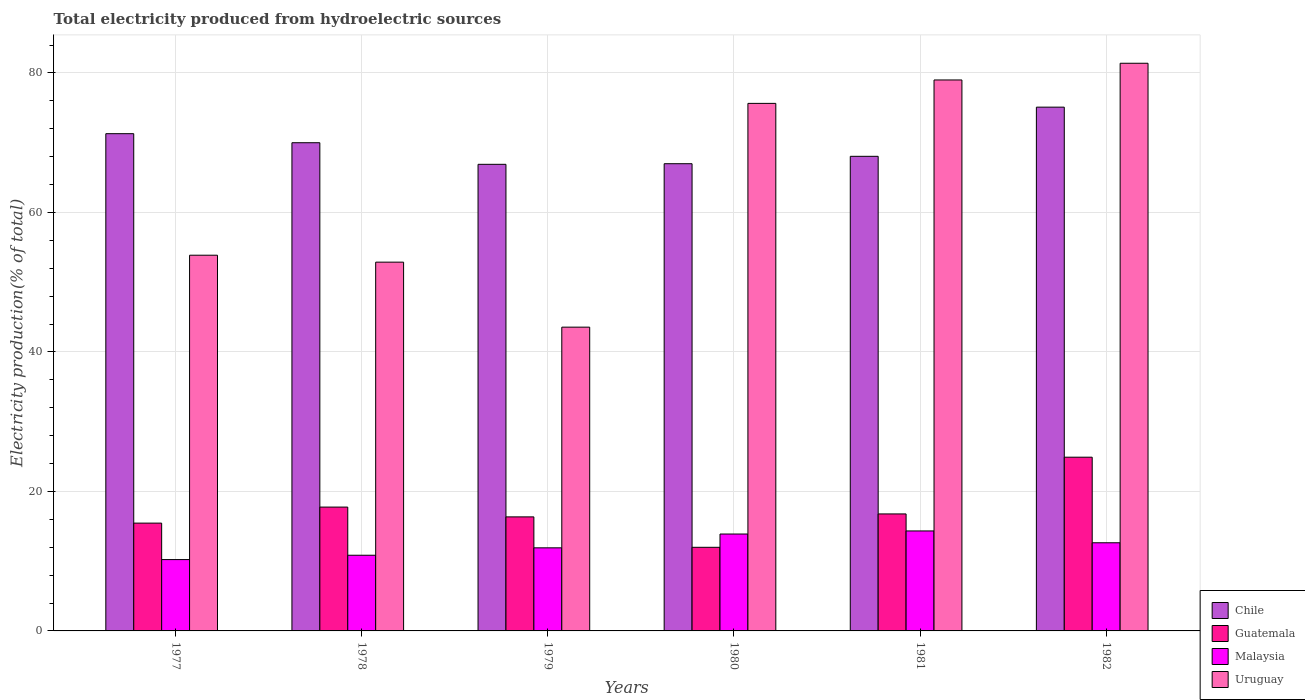How many groups of bars are there?
Ensure brevity in your answer.  6. How many bars are there on the 1st tick from the left?
Offer a terse response. 4. How many bars are there on the 3rd tick from the right?
Offer a terse response. 4. What is the label of the 4th group of bars from the left?
Your answer should be compact. 1980. What is the total electricity produced in Chile in 1977?
Your answer should be very brief. 71.29. Across all years, what is the maximum total electricity produced in Chile?
Your answer should be very brief. 75.09. Across all years, what is the minimum total electricity produced in Chile?
Provide a succinct answer. 66.89. In which year was the total electricity produced in Guatemala maximum?
Make the answer very short. 1982. In which year was the total electricity produced in Malaysia minimum?
Your answer should be very brief. 1977. What is the total total electricity produced in Malaysia in the graph?
Provide a succinct answer. 73.85. What is the difference between the total electricity produced in Malaysia in 1977 and that in 1978?
Keep it short and to the point. -0.62. What is the difference between the total electricity produced in Chile in 1982 and the total electricity produced in Malaysia in 1980?
Give a very brief answer. 61.2. What is the average total electricity produced in Malaysia per year?
Your answer should be compact. 12.31. In the year 1979, what is the difference between the total electricity produced in Malaysia and total electricity produced in Guatemala?
Your response must be concise. -4.44. In how many years, is the total electricity produced in Malaysia greater than 56 %?
Your answer should be very brief. 0. What is the ratio of the total electricity produced in Malaysia in 1980 to that in 1982?
Provide a short and direct response. 1.1. Is the difference between the total electricity produced in Malaysia in 1979 and 1981 greater than the difference between the total electricity produced in Guatemala in 1979 and 1981?
Offer a terse response. No. What is the difference between the highest and the second highest total electricity produced in Chile?
Your answer should be compact. 3.8. What is the difference between the highest and the lowest total electricity produced in Uruguay?
Provide a short and direct response. 37.83. Is the sum of the total electricity produced in Uruguay in 1978 and 1982 greater than the maximum total electricity produced in Chile across all years?
Make the answer very short. Yes. Is it the case that in every year, the sum of the total electricity produced in Malaysia and total electricity produced in Uruguay is greater than the sum of total electricity produced in Guatemala and total electricity produced in Chile?
Offer a very short reply. Yes. What does the 2nd bar from the left in 1979 represents?
Keep it short and to the point. Guatemala. What does the 4th bar from the right in 1979 represents?
Your answer should be compact. Chile. Are all the bars in the graph horizontal?
Your answer should be compact. No. How many years are there in the graph?
Give a very brief answer. 6. What is the difference between two consecutive major ticks on the Y-axis?
Your response must be concise. 20. Are the values on the major ticks of Y-axis written in scientific E-notation?
Keep it short and to the point. No. Where does the legend appear in the graph?
Your answer should be very brief. Bottom right. How many legend labels are there?
Your response must be concise. 4. How are the legend labels stacked?
Your answer should be very brief. Vertical. What is the title of the graph?
Your answer should be very brief. Total electricity produced from hydroelectric sources. Does "Iceland" appear as one of the legend labels in the graph?
Keep it short and to the point. No. What is the Electricity production(% of total) in Chile in 1977?
Offer a terse response. 71.29. What is the Electricity production(% of total) in Guatemala in 1977?
Offer a very short reply. 15.46. What is the Electricity production(% of total) in Malaysia in 1977?
Make the answer very short. 10.23. What is the Electricity production(% of total) of Uruguay in 1977?
Provide a short and direct response. 53.86. What is the Electricity production(% of total) of Chile in 1978?
Provide a short and direct response. 69.99. What is the Electricity production(% of total) in Guatemala in 1978?
Offer a terse response. 17.75. What is the Electricity production(% of total) of Malaysia in 1978?
Offer a very short reply. 10.85. What is the Electricity production(% of total) of Uruguay in 1978?
Give a very brief answer. 52.87. What is the Electricity production(% of total) of Chile in 1979?
Offer a very short reply. 66.89. What is the Electricity production(% of total) of Guatemala in 1979?
Provide a succinct answer. 16.35. What is the Electricity production(% of total) of Malaysia in 1979?
Your response must be concise. 11.91. What is the Electricity production(% of total) of Uruguay in 1979?
Keep it short and to the point. 43.55. What is the Electricity production(% of total) of Chile in 1980?
Make the answer very short. 66.98. What is the Electricity production(% of total) of Guatemala in 1980?
Your response must be concise. 11.99. What is the Electricity production(% of total) in Malaysia in 1980?
Your response must be concise. 13.89. What is the Electricity production(% of total) in Uruguay in 1980?
Your response must be concise. 75.63. What is the Electricity production(% of total) in Chile in 1981?
Make the answer very short. 68.04. What is the Electricity production(% of total) in Guatemala in 1981?
Ensure brevity in your answer.  16.77. What is the Electricity production(% of total) of Malaysia in 1981?
Provide a succinct answer. 14.33. What is the Electricity production(% of total) of Uruguay in 1981?
Your answer should be very brief. 78.99. What is the Electricity production(% of total) in Chile in 1982?
Your response must be concise. 75.09. What is the Electricity production(% of total) in Guatemala in 1982?
Your answer should be very brief. 24.91. What is the Electricity production(% of total) of Malaysia in 1982?
Make the answer very short. 12.64. What is the Electricity production(% of total) in Uruguay in 1982?
Your response must be concise. 81.38. Across all years, what is the maximum Electricity production(% of total) of Chile?
Keep it short and to the point. 75.09. Across all years, what is the maximum Electricity production(% of total) of Guatemala?
Offer a terse response. 24.91. Across all years, what is the maximum Electricity production(% of total) in Malaysia?
Your answer should be compact. 14.33. Across all years, what is the maximum Electricity production(% of total) in Uruguay?
Give a very brief answer. 81.38. Across all years, what is the minimum Electricity production(% of total) in Chile?
Make the answer very short. 66.89. Across all years, what is the minimum Electricity production(% of total) in Guatemala?
Ensure brevity in your answer.  11.99. Across all years, what is the minimum Electricity production(% of total) of Malaysia?
Give a very brief answer. 10.23. Across all years, what is the minimum Electricity production(% of total) of Uruguay?
Give a very brief answer. 43.55. What is the total Electricity production(% of total) of Chile in the graph?
Your response must be concise. 418.28. What is the total Electricity production(% of total) of Guatemala in the graph?
Your answer should be very brief. 103.23. What is the total Electricity production(% of total) of Malaysia in the graph?
Make the answer very short. 73.85. What is the total Electricity production(% of total) in Uruguay in the graph?
Ensure brevity in your answer.  386.29. What is the difference between the Electricity production(% of total) in Chile in 1977 and that in 1978?
Your answer should be compact. 1.3. What is the difference between the Electricity production(% of total) of Guatemala in 1977 and that in 1978?
Give a very brief answer. -2.3. What is the difference between the Electricity production(% of total) of Malaysia in 1977 and that in 1978?
Ensure brevity in your answer.  -0.62. What is the difference between the Electricity production(% of total) in Uruguay in 1977 and that in 1978?
Your response must be concise. 1. What is the difference between the Electricity production(% of total) of Chile in 1977 and that in 1979?
Your answer should be compact. 4.39. What is the difference between the Electricity production(% of total) in Guatemala in 1977 and that in 1979?
Make the answer very short. -0.89. What is the difference between the Electricity production(% of total) in Malaysia in 1977 and that in 1979?
Make the answer very short. -1.69. What is the difference between the Electricity production(% of total) in Uruguay in 1977 and that in 1979?
Ensure brevity in your answer.  10.31. What is the difference between the Electricity production(% of total) of Chile in 1977 and that in 1980?
Offer a terse response. 4.31. What is the difference between the Electricity production(% of total) of Guatemala in 1977 and that in 1980?
Keep it short and to the point. 3.47. What is the difference between the Electricity production(% of total) of Malaysia in 1977 and that in 1980?
Provide a succinct answer. -3.67. What is the difference between the Electricity production(% of total) in Uruguay in 1977 and that in 1980?
Your response must be concise. -21.77. What is the difference between the Electricity production(% of total) in Chile in 1977 and that in 1981?
Provide a succinct answer. 3.25. What is the difference between the Electricity production(% of total) in Guatemala in 1977 and that in 1981?
Provide a short and direct response. -1.32. What is the difference between the Electricity production(% of total) in Malaysia in 1977 and that in 1981?
Offer a very short reply. -4.11. What is the difference between the Electricity production(% of total) of Uruguay in 1977 and that in 1981?
Ensure brevity in your answer.  -25.12. What is the difference between the Electricity production(% of total) of Chile in 1977 and that in 1982?
Keep it short and to the point. -3.8. What is the difference between the Electricity production(% of total) in Guatemala in 1977 and that in 1982?
Provide a short and direct response. -9.45. What is the difference between the Electricity production(% of total) of Malaysia in 1977 and that in 1982?
Offer a very short reply. -2.41. What is the difference between the Electricity production(% of total) of Uruguay in 1977 and that in 1982?
Provide a succinct answer. -27.52. What is the difference between the Electricity production(% of total) in Chile in 1978 and that in 1979?
Offer a terse response. 3.1. What is the difference between the Electricity production(% of total) of Guatemala in 1978 and that in 1979?
Offer a terse response. 1.4. What is the difference between the Electricity production(% of total) in Malaysia in 1978 and that in 1979?
Offer a terse response. -1.06. What is the difference between the Electricity production(% of total) of Uruguay in 1978 and that in 1979?
Your response must be concise. 9.32. What is the difference between the Electricity production(% of total) of Chile in 1978 and that in 1980?
Your response must be concise. 3.01. What is the difference between the Electricity production(% of total) in Guatemala in 1978 and that in 1980?
Keep it short and to the point. 5.77. What is the difference between the Electricity production(% of total) in Malaysia in 1978 and that in 1980?
Keep it short and to the point. -3.04. What is the difference between the Electricity production(% of total) in Uruguay in 1978 and that in 1980?
Offer a very short reply. -22.76. What is the difference between the Electricity production(% of total) of Chile in 1978 and that in 1981?
Keep it short and to the point. 1.95. What is the difference between the Electricity production(% of total) of Guatemala in 1978 and that in 1981?
Provide a succinct answer. 0.98. What is the difference between the Electricity production(% of total) in Malaysia in 1978 and that in 1981?
Provide a succinct answer. -3.48. What is the difference between the Electricity production(% of total) of Uruguay in 1978 and that in 1981?
Give a very brief answer. -26.12. What is the difference between the Electricity production(% of total) in Chile in 1978 and that in 1982?
Your answer should be very brief. -5.1. What is the difference between the Electricity production(% of total) of Guatemala in 1978 and that in 1982?
Provide a short and direct response. -7.15. What is the difference between the Electricity production(% of total) of Malaysia in 1978 and that in 1982?
Make the answer very short. -1.79. What is the difference between the Electricity production(% of total) in Uruguay in 1978 and that in 1982?
Offer a very short reply. -28.52. What is the difference between the Electricity production(% of total) of Chile in 1979 and that in 1980?
Offer a terse response. -0.09. What is the difference between the Electricity production(% of total) of Guatemala in 1979 and that in 1980?
Your answer should be compact. 4.36. What is the difference between the Electricity production(% of total) in Malaysia in 1979 and that in 1980?
Keep it short and to the point. -1.98. What is the difference between the Electricity production(% of total) of Uruguay in 1979 and that in 1980?
Offer a terse response. -32.08. What is the difference between the Electricity production(% of total) in Chile in 1979 and that in 1981?
Your answer should be very brief. -1.15. What is the difference between the Electricity production(% of total) in Guatemala in 1979 and that in 1981?
Your answer should be compact. -0.42. What is the difference between the Electricity production(% of total) in Malaysia in 1979 and that in 1981?
Provide a short and direct response. -2.42. What is the difference between the Electricity production(% of total) in Uruguay in 1979 and that in 1981?
Your answer should be compact. -35.44. What is the difference between the Electricity production(% of total) of Chile in 1979 and that in 1982?
Provide a short and direct response. -8.2. What is the difference between the Electricity production(% of total) of Guatemala in 1979 and that in 1982?
Offer a very short reply. -8.56. What is the difference between the Electricity production(% of total) of Malaysia in 1979 and that in 1982?
Ensure brevity in your answer.  -0.73. What is the difference between the Electricity production(% of total) in Uruguay in 1979 and that in 1982?
Provide a short and direct response. -37.83. What is the difference between the Electricity production(% of total) of Chile in 1980 and that in 1981?
Your response must be concise. -1.06. What is the difference between the Electricity production(% of total) in Guatemala in 1980 and that in 1981?
Your answer should be very brief. -4.79. What is the difference between the Electricity production(% of total) of Malaysia in 1980 and that in 1981?
Keep it short and to the point. -0.44. What is the difference between the Electricity production(% of total) of Uruguay in 1980 and that in 1981?
Ensure brevity in your answer.  -3.36. What is the difference between the Electricity production(% of total) in Chile in 1980 and that in 1982?
Ensure brevity in your answer.  -8.11. What is the difference between the Electricity production(% of total) in Guatemala in 1980 and that in 1982?
Ensure brevity in your answer.  -12.92. What is the difference between the Electricity production(% of total) of Malaysia in 1980 and that in 1982?
Give a very brief answer. 1.25. What is the difference between the Electricity production(% of total) of Uruguay in 1980 and that in 1982?
Ensure brevity in your answer.  -5.75. What is the difference between the Electricity production(% of total) of Chile in 1981 and that in 1982?
Keep it short and to the point. -7.05. What is the difference between the Electricity production(% of total) of Guatemala in 1981 and that in 1982?
Offer a very short reply. -8.13. What is the difference between the Electricity production(% of total) of Malaysia in 1981 and that in 1982?
Ensure brevity in your answer.  1.7. What is the difference between the Electricity production(% of total) in Uruguay in 1981 and that in 1982?
Your response must be concise. -2.4. What is the difference between the Electricity production(% of total) of Chile in 1977 and the Electricity production(% of total) of Guatemala in 1978?
Ensure brevity in your answer.  53.53. What is the difference between the Electricity production(% of total) in Chile in 1977 and the Electricity production(% of total) in Malaysia in 1978?
Ensure brevity in your answer.  60.44. What is the difference between the Electricity production(% of total) in Chile in 1977 and the Electricity production(% of total) in Uruguay in 1978?
Give a very brief answer. 18.42. What is the difference between the Electricity production(% of total) of Guatemala in 1977 and the Electricity production(% of total) of Malaysia in 1978?
Your answer should be compact. 4.61. What is the difference between the Electricity production(% of total) in Guatemala in 1977 and the Electricity production(% of total) in Uruguay in 1978?
Your answer should be very brief. -37.41. What is the difference between the Electricity production(% of total) of Malaysia in 1977 and the Electricity production(% of total) of Uruguay in 1978?
Your answer should be very brief. -42.64. What is the difference between the Electricity production(% of total) of Chile in 1977 and the Electricity production(% of total) of Guatemala in 1979?
Keep it short and to the point. 54.94. What is the difference between the Electricity production(% of total) of Chile in 1977 and the Electricity production(% of total) of Malaysia in 1979?
Provide a short and direct response. 59.38. What is the difference between the Electricity production(% of total) in Chile in 1977 and the Electricity production(% of total) in Uruguay in 1979?
Your response must be concise. 27.74. What is the difference between the Electricity production(% of total) of Guatemala in 1977 and the Electricity production(% of total) of Malaysia in 1979?
Your answer should be very brief. 3.54. What is the difference between the Electricity production(% of total) in Guatemala in 1977 and the Electricity production(% of total) in Uruguay in 1979?
Offer a terse response. -28.1. What is the difference between the Electricity production(% of total) of Malaysia in 1977 and the Electricity production(% of total) of Uruguay in 1979?
Your response must be concise. -33.33. What is the difference between the Electricity production(% of total) in Chile in 1977 and the Electricity production(% of total) in Guatemala in 1980?
Offer a terse response. 59.3. What is the difference between the Electricity production(% of total) of Chile in 1977 and the Electricity production(% of total) of Malaysia in 1980?
Provide a succinct answer. 57.39. What is the difference between the Electricity production(% of total) of Chile in 1977 and the Electricity production(% of total) of Uruguay in 1980?
Provide a short and direct response. -4.34. What is the difference between the Electricity production(% of total) in Guatemala in 1977 and the Electricity production(% of total) in Malaysia in 1980?
Ensure brevity in your answer.  1.56. What is the difference between the Electricity production(% of total) of Guatemala in 1977 and the Electricity production(% of total) of Uruguay in 1980?
Provide a short and direct response. -60.17. What is the difference between the Electricity production(% of total) of Malaysia in 1977 and the Electricity production(% of total) of Uruguay in 1980?
Provide a short and direct response. -65.4. What is the difference between the Electricity production(% of total) in Chile in 1977 and the Electricity production(% of total) in Guatemala in 1981?
Keep it short and to the point. 54.51. What is the difference between the Electricity production(% of total) of Chile in 1977 and the Electricity production(% of total) of Malaysia in 1981?
Your response must be concise. 56.95. What is the difference between the Electricity production(% of total) of Chile in 1977 and the Electricity production(% of total) of Uruguay in 1981?
Offer a very short reply. -7.7. What is the difference between the Electricity production(% of total) of Guatemala in 1977 and the Electricity production(% of total) of Malaysia in 1981?
Make the answer very short. 1.12. What is the difference between the Electricity production(% of total) of Guatemala in 1977 and the Electricity production(% of total) of Uruguay in 1981?
Give a very brief answer. -63.53. What is the difference between the Electricity production(% of total) in Malaysia in 1977 and the Electricity production(% of total) in Uruguay in 1981?
Give a very brief answer. -68.76. What is the difference between the Electricity production(% of total) in Chile in 1977 and the Electricity production(% of total) in Guatemala in 1982?
Provide a short and direct response. 46.38. What is the difference between the Electricity production(% of total) in Chile in 1977 and the Electricity production(% of total) in Malaysia in 1982?
Make the answer very short. 58.65. What is the difference between the Electricity production(% of total) in Chile in 1977 and the Electricity production(% of total) in Uruguay in 1982?
Keep it short and to the point. -10.1. What is the difference between the Electricity production(% of total) in Guatemala in 1977 and the Electricity production(% of total) in Malaysia in 1982?
Ensure brevity in your answer.  2.82. What is the difference between the Electricity production(% of total) in Guatemala in 1977 and the Electricity production(% of total) in Uruguay in 1982?
Give a very brief answer. -65.93. What is the difference between the Electricity production(% of total) of Malaysia in 1977 and the Electricity production(% of total) of Uruguay in 1982?
Keep it short and to the point. -71.16. What is the difference between the Electricity production(% of total) of Chile in 1978 and the Electricity production(% of total) of Guatemala in 1979?
Offer a terse response. 53.64. What is the difference between the Electricity production(% of total) in Chile in 1978 and the Electricity production(% of total) in Malaysia in 1979?
Ensure brevity in your answer.  58.08. What is the difference between the Electricity production(% of total) in Chile in 1978 and the Electricity production(% of total) in Uruguay in 1979?
Offer a very short reply. 26.44. What is the difference between the Electricity production(% of total) in Guatemala in 1978 and the Electricity production(% of total) in Malaysia in 1979?
Offer a terse response. 5.84. What is the difference between the Electricity production(% of total) in Guatemala in 1978 and the Electricity production(% of total) in Uruguay in 1979?
Give a very brief answer. -25.8. What is the difference between the Electricity production(% of total) in Malaysia in 1978 and the Electricity production(% of total) in Uruguay in 1979?
Ensure brevity in your answer.  -32.7. What is the difference between the Electricity production(% of total) in Chile in 1978 and the Electricity production(% of total) in Guatemala in 1980?
Your answer should be compact. 58. What is the difference between the Electricity production(% of total) in Chile in 1978 and the Electricity production(% of total) in Malaysia in 1980?
Your response must be concise. 56.1. What is the difference between the Electricity production(% of total) of Chile in 1978 and the Electricity production(% of total) of Uruguay in 1980?
Offer a very short reply. -5.64. What is the difference between the Electricity production(% of total) in Guatemala in 1978 and the Electricity production(% of total) in Malaysia in 1980?
Ensure brevity in your answer.  3.86. What is the difference between the Electricity production(% of total) of Guatemala in 1978 and the Electricity production(% of total) of Uruguay in 1980?
Your answer should be very brief. -57.88. What is the difference between the Electricity production(% of total) of Malaysia in 1978 and the Electricity production(% of total) of Uruguay in 1980?
Provide a short and direct response. -64.78. What is the difference between the Electricity production(% of total) of Chile in 1978 and the Electricity production(% of total) of Guatemala in 1981?
Give a very brief answer. 53.22. What is the difference between the Electricity production(% of total) in Chile in 1978 and the Electricity production(% of total) in Malaysia in 1981?
Make the answer very short. 55.66. What is the difference between the Electricity production(% of total) in Chile in 1978 and the Electricity production(% of total) in Uruguay in 1981?
Your response must be concise. -9. What is the difference between the Electricity production(% of total) of Guatemala in 1978 and the Electricity production(% of total) of Malaysia in 1981?
Offer a terse response. 3.42. What is the difference between the Electricity production(% of total) in Guatemala in 1978 and the Electricity production(% of total) in Uruguay in 1981?
Your answer should be compact. -61.23. What is the difference between the Electricity production(% of total) of Malaysia in 1978 and the Electricity production(% of total) of Uruguay in 1981?
Provide a short and direct response. -68.14. What is the difference between the Electricity production(% of total) in Chile in 1978 and the Electricity production(% of total) in Guatemala in 1982?
Offer a terse response. 45.08. What is the difference between the Electricity production(% of total) in Chile in 1978 and the Electricity production(% of total) in Malaysia in 1982?
Give a very brief answer. 57.35. What is the difference between the Electricity production(% of total) in Chile in 1978 and the Electricity production(% of total) in Uruguay in 1982?
Your answer should be compact. -11.39. What is the difference between the Electricity production(% of total) of Guatemala in 1978 and the Electricity production(% of total) of Malaysia in 1982?
Offer a terse response. 5.12. What is the difference between the Electricity production(% of total) in Guatemala in 1978 and the Electricity production(% of total) in Uruguay in 1982?
Your answer should be very brief. -63.63. What is the difference between the Electricity production(% of total) in Malaysia in 1978 and the Electricity production(% of total) in Uruguay in 1982?
Offer a terse response. -70.53. What is the difference between the Electricity production(% of total) of Chile in 1979 and the Electricity production(% of total) of Guatemala in 1980?
Give a very brief answer. 54.91. What is the difference between the Electricity production(% of total) of Chile in 1979 and the Electricity production(% of total) of Malaysia in 1980?
Offer a terse response. 53. What is the difference between the Electricity production(% of total) of Chile in 1979 and the Electricity production(% of total) of Uruguay in 1980?
Provide a succinct answer. -8.74. What is the difference between the Electricity production(% of total) of Guatemala in 1979 and the Electricity production(% of total) of Malaysia in 1980?
Provide a succinct answer. 2.46. What is the difference between the Electricity production(% of total) in Guatemala in 1979 and the Electricity production(% of total) in Uruguay in 1980?
Your answer should be very brief. -59.28. What is the difference between the Electricity production(% of total) in Malaysia in 1979 and the Electricity production(% of total) in Uruguay in 1980?
Your answer should be compact. -63.72. What is the difference between the Electricity production(% of total) of Chile in 1979 and the Electricity production(% of total) of Guatemala in 1981?
Offer a terse response. 50.12. What is the difference between the Electricity production(% of total) of Chile in 1979 and the Electricity production(% of total) of Malaysia in 1981?
Give a very brief answer. 52.56. What is the difference between the Electricity production(% of total) in Chile in 1979 and the Electricity production(% of total) in Uruguay in 1981?
Make the answer very short. -12.09. What is the difference between the Electricity production(% of total) of Guatemala in 1979 and the Electricity production(% of total) of Malaysia in 1981?
Provide a short and direct response. 2.02. What is the difference between the Electricity production(% of total) of Guatemala in 1979 and the Electricity production(% of total) of Uruguay in 1981?
Make the answer very short. -62.64. What is the difference between the Electricity production(% of total) of Malaysia in 1979 and the Electricity production(% of total) of Uruguay in 1981?
Offer a very short reply. -67.08. What is the difference between the Electricity production(% of total) of Chile in 1979 and the Electricity production(% of total) of Guatemala in 1982?
Make the answer very short. 41.99. What is the difference between the Electricity production(% of total) of Chile in 1979 and the Electricity production(% of total) of Malaysia in 1982?
Ensure brevity in your answer.  54.26. What is the difference between the Electricity production(% of total) in Chile in 1979 and the Electricity production(% of total) in Uruguay in 1982?
Provide a short and direct response. -14.49. What is the difference between the Electricity production(% of total) in Guatemala in 1979 and the Electricity production(% of total) in Malaysia in 1982?
Give a very brief answer. 3.71. What is the difference between the Electricity production(% of total) in Guatemala in 1979 and the Electricity production(% of total) in Uruguay in 1982?
Your answer should be very brief. -65.03. What is the difference between the Electricity production(% of total) of Malaysia in 1979 and the Electricity production(% of total) of Uruguay in 1982?
Your response must be concise. -69.47. What is the difference between the Electricity production(% of total) of Chile in 1980 and the Electricity production(% of total) of Guatemala in 1981?
Offer a very short reply. 50.21. What is the difference between the Electricity production(% of total) of Chile in 1980 and the Electricity production(% of total) of Malaysia in 1981?
Keep it short and to the point. 52.65. What is the difference between the Electricity production(% of total) in Chile in 1980 and the Electricity production(% of total) in Uruguay in 1981?
Provide a succinct answer. -12.01. What is the difference between the Electricity production(% of total) in Guatemala in 1980 and the Electricity production(% of total) in Malaysia in 1981?
Your answer should be compact. -2.35. What is the difference between the Electricity production(% of total) in Guatemala in 1980 and the Electricity production(% of total) in Uruguay in 1981?
Ensure brevity in your answer.  -67. What is the difference between the Electricity production(% of total) of Malaysia in 1980 and the Electricity production(% of total) of Uruguay in 1981?
Ensure brevity in your answer.  -65.1. What is the difference between the Electricity production(% of total) of Chile in 1980 and the Electricity production(% of total) of Guatemala in 1982?
Make the answer very short. 42.08. What is the difference between the Electricity production(% of total) of Chile in 1980 and the Electricity production(% of total) of Malaysia in 1982?
Provide a short and direct response. 54.34. What is the difference between the Electricity production(% of total) of Chile in 1980 and the Electricity production(% of total) of Uruguay in 1982?
Offer a terse response. -14.4. What is the difference between the Electricity production(% of total) of Guatemala in 1980 and the Electricity production(% of total) of Malaysia in 1982?
Your answer should be very brief. -0.65. What is the difference between the Electricity production(% of total) of Guatemala in 1980 and the Electricity production(% of total) of Uruguay in 1982?
Offer a very short reply. -69.4. What is the difference between the Electricity production(% of total) in Malaysia in 1980 and the Electricity production(% of total) in Uruguay in 1982?
Keep it short and to the point. -67.49. What is the difference between the Electricity production(% of total) of Chile in 1981 and the Electricity production(% of total) of Guatemala in 1982?
Ensure brevity in your answer.  43.14. What is the difference between the Electricity production(% of total) in Chile in 1981 and the Electricity production(% of total) in Malaysia in 1982?
Ensure brevity in your answer.  55.4. What is the difference between the Electricity production(% of total) in Chile in 1981 and the Electricity production(% of total) in Uruguay in 1982?
Your response must be concise. -13.34. What is the difference between the Electricity production(% of total) of Guatemala in 1981 and the Electricity production(% of total) of Malaysia in 1982?
Give a very brief answer. 4.14. What is the difference between the Electricity production(% of total) of Guatemala in 1981 and the Electricity production(% of total) of Uruguay in 1982?
Offer a terse response. -64.61. What is the difference between the Electricity production(% of total) of Malaysia in 1981 and the Electricity production(% of total) of Uruguay in 1982?
Your answer should be compact. -67.05. What is the average Electricity production(% of total) in Chile per year?
Offer a very short reply. 69.71. What is the average Electricity production(% of total) of Guatemala per year?
Give a very brief answer. 17.2. What is the average Electricity production(% of total) in Malaysia per year?
Keep it short and to the point. 12.31. What is the average Electricity production(% of total) of Uruguay per year?
Provide a succinct answer. 64.38. In the year 1977, what is the difference between the Electricity production(% of total) in Chile and Electricity production(% of total) in Guatemala?
Ensure brevity in your answer.  55.83. In the year 1977, what is the difference between the Electricity production(% of total) of Chile and Electricity production(% of total) of Malaysia?
Offer a very short reply. 61.06. In the year 1977, what is the difference between the Electricity production(% of total) of Chile and Electricity production(% of total) of Uruguay?
Keep it short and to the point. 17.42. In the year 1977, what is the difference between the Electricity production(% of total) in Guatemala and Electricity production(% of total) in Malaysia?
Offer a very short reply. 5.23. In the year 1977, what is the difference between the Electricity production(% of total) in Guatemala and Electricity production(% of total) in Uruguay?
Make the answer very short. -38.41. In the year 1977, what is the difference between the Electricity production(% of total) of Malaysia and Electricity production(% of total) of Uruguay?
Provide a succinct answer. -43.64. In the year 1978, what is the difference between the Electricity production(% of total) of Chile and Electricity production(% of total) of Guatemala?
Provide a succinct answer. 52.24. In the year 1978, what is the difference between the Electricity production(% of total) of Chile and Electricity production(% of total) of Malaysia?
Your response must be concise. 59.14. In the year 1978, what is the difference between the Electricity production(% of total) of Chile and Electricity production(% of total) of Uruguay?
Your answer should be very brief. 17.12. In the year 1978, what is the difference between the Electricity production(% of total) of Guatemala and Electricity production(% of total) of Malaysia?
Ensure brevity in your answer.  6.9. In the year 1978, what is the difference between the Electricity production(% of total) in Guatemala and Electricity production(% of total) in Uruguay?
Give a very brief answer. -35.11. In the year 1978, what is the difference between the Electricity production(% of total) in Malaysia and Electricity production(% of total) in Uruguay?
Your response must be concise. -42.02. In the year 1979, what is the difference between the Electricity production(% of total) in Chile and Electricity production(% of total) in Guatemala?
Ensure brevity in your answer.  50.54. In the year 1979, what is the difference between the Electricity production(% of total) in Chile and Electricity production(% of total) in Malaysia?
Give a very brief answer. 54.98. In the year 1979, what is the difference between the Electricity production(% of total) in Chile and Electricity production(% of total) in Uruguay?
Provide a succinct answer. 23.34. In the year 1979, what is the difference between the Electricity production(% of total) of Guatemala and Electricity production(% of total) of Malaysia?
Provide a short and direct response. 4.44. In the year 1979, what is the difference between the Electricity production(% of total) in Guatemala and Electricity production(% of total) in Uruguay?
Keep it short and to the point. -27.2. In the year 1979, what is the difference between the Electricity production(% of total) in Malaysia and Electricity production(% of total) in Uruguay?
Your answer should be compact. -31.64. In the year 1980, what is the difference between the Electricity production(% of total) of Chile and Electricity production(% of total) of Guatemala?
Your answer should be compact. 54.99. In the year 1980, what is the difference between the Electricity production(% of total) in Chile and Electricity production(% of total) in Malaysia?
Offer a very short reply. 53.09. In the year 1980, what is the difference between the Electricity production(% of total) of Chile and Electricity production(% of total) of Uruguay?
Make the answer very short. -8.65. In the year 1980, what is the difference between the Electricity production(% of total) in Guatemala and Electricity production(% of total) in Malaysia?
Keep it short and to the point. -1.9. In the year 1980, what is the difference between the Electricity production(% of total) in Guatemala and Electricity production(% of total) in Uruguay?
Make the answer very short. -63.64. In the year 1980, what is the difference between the Electricity production(% of total) in Malaysia and Electricity production(% of total) in Uruguay?
Provide a short and direct response. -61.74. In the year 1981, what is the difference between the Electricity production(% of total) of Chile and Electricity production(% of total) of Guatemala?
Offer a terse response. 51.27. In the year 1981, what is the difference between the Electricity production(% of total) of Chile and Electricity production(% of total) of Malaysia?
Give a very brief answer. 53.71. In the year 1981, what is the difference between the Electricity production(% of total) in Chile and Electricity production(% of total) in Uruguay?
Provide a short and direct response. -10.95. In the year 1981, what is the difference between the Electricity production(% of total) of Guatemala and Electricity production(% of total) of Malaysia?
Make the answer very short. 2.44. In the year 1981, what is the difference between the Electricity production(% of total) of Guatemala and Electricity production(% of total) of Uruguay?
Make the answer very short. -62.21. In the year 1981, what is the difference between the Electricity production(% of total) in Malaysia and Electricity production(% of total) in Uruguay?
Give a very brief answer. -64.66. In the year 1982, what is the difference between the Electricity production(% of total) of Chile and Electricity production(% of total) of Guatemala?
Offer a terse response. 50.18. In the year 1982, what is the difference between the Electricity production(% of total) of Chile and Electricity production(% of total) of Malaysia?
Offer a terse response. 62.45. In the year 1982, what is the difference between the Electricity production(% of total) in Chile and Electricity production(% of total) in Uruguay?
Provide a short and direct response. -6.29. In the year 1982, what is the difference between the Electricity production(% of total) of Guatemala and Electricity production(% of total) of Malaysia?
Offer a very short reply. 12.27. In the year 1982, what is the difference between the Electricity production(% of total) in Guatemala and Electricity production(% of total) in Uruguay?
Make the answer very short. -56.48. In the year 1982, what is the difference between the Electricity production(% of total) of Malaysia and Electricity production(% of total) of Uruguay?
Ensure brevity in your answer.  -68.75. What is the ratio of the Electricity production(% of total) in Chile in 1977 to that in 1978?
Keep it short and to the point. 1.02. What is the ratio of the Electricity production(% of total) in Guatemala in 1977 to that in 1978?
Keep it short and to the point. 0.87. What is the ratio of the Electricity production(% of total) in Malaysia in 1977 to that in 1978?
Give a very brief answer. 0.94. What is the ratio of the Electricity production(% of total) in Uruguay in 1977 to that in 1978?
Offer a very short reply. 1.02. What is the ratio of the Electricity production(% of total) in Chile in 1977 to that in 1979?
Your answer should be very brief. 1.07. What is the ratio of the Electricity production(% of total) of Guatemala in 1977 to that in 1979?
Ensure brevity in your answer.  0.95. What is the ratio of the Electricity production(% of total) in Malaysia in 1977 to that in 1979?
Offer a terse response. 0.86. What is the ratio of the Electricity production(% of total) of Uruguay in 1977 to that in 1979?
Offer a very short reply. 1.24. What is the ratio of the Electricity production(% of total) of Chile in 1977 to that in 1980?
Provide a succinct answer. 1.06. What is the ratio of the Electricity production(% of total) in Guatemala in 1977 to that in 1980?
Your answer should be compact. 1.29. What is the ratio of the Electricity production(% of total) of Malaysia in 1977 to that in 1980?
Give a very brief answer. 0.74. What is the ratio of the Electricity production(% of total) in Uruguay in 1977 to that in 1980?
Make the answer very short. 0.71. What is the ratio of the Electricity production(% of total) in Chile in 1977 to that in 1981?
Provide a short and direct response. 1.05. What is the ratio of the Electricity production(% of total) in Guatemala in 1977 to that in 1981?
Ensure brevity in your answer.  0.92. What is the ratio of the Electricity production(% of total) of Malaysia in 1977 to that in 1981?
Give a very brief answer. 0.71. What is the ratio of the Electricity production(% of total) of Uruguay in 1977 to that in 1981?
Ensure brevity in your answer.  0.68. What is the ratio of the Electricity production(% of total) in Chile in 1977 to that in 1982?
Ensure brevity in your answer.  0.95. What is the ratio of the Electricity production(% of total) of Guatemala in 1977 to that in 1982?
Ensure brevity in your answer.  0.62. What is the ratio of the Electricity production(% of total) of Malaysia in 1977 to that in 1982?
Your answer should be compact. 0.81. What is the ratio of the Electricity production(% of total) of Uruguay in 1977 to that in 1982?
Make the answer very short. 0.66. What is the ratio of the Electricity production(% of total) of Chile in 1978 to that in 1979?
Give a very brief answer. 1.05. What is the ratio of the Electricity production(% of total) of Guatemala in 1978 to that in 1979?
Offer a terse response. 1.09. What is the ratio of the Electricity production(% of total) of Malaysia in 1978 to that in 1979?
Your response must be concise. 0.91. What is the ratio of the Electricity production(% of total) in Uruguay in 1978 to that in 1979?
Your response must be concise. 1.21. What is the ratio of the Electricity production(% of total) in Chile in 1978 to that in 1980?
Provide a short and direct response. 1.04. What is the ratio of the Electricity production(% of total) of Guatemala in 1978 to that in 1980?
Provide a succinct answer. 1.48. What is the ratio of the Electricity production(% of total) in Malaysia in 1978 to that in 1980?
Your answer should be compact. 0.78. What is the ratio of the Electricity production(% of total) in Uruguay in 1978 to that in 1980?
Your answer should be compact. 0.7. What is the ratio of the Electricity production(% of total) in Chile in 1978 to that in 1981?
Offer a very short reply. 1.03. What is the ratio of the Electricity production(% of total) of Guatemala in 1978 to that in 1981?
Give a very brief answer. 1.06. What is the ratio of the Electricity production(% of total) in Malaysia in 1978 to that in 1981?
Provide a short and direct response. 0.76. What is the ratio of the Electricity production(% of total) of Uruguay in 1978 to that in 1981?
Offer a very short reply. 0.67. What is the ratio of the Electricity production(% of total) of Chile in 1978 to that in 1982?
Provide a short and direct response. 0.93. What is the ratio of the Electricity production(% of total) in Guatemala in 1978 to that in 1982?
Your response must be concise. 0.71. What is the ratio of the Electricity production(% of total) of Malaysia in 1978 to that in 1982?
Your response must be concise. 0.86. What is the ratio of the Electricity production(% of total) in Uruguay in 1978 to that in 1982?
Keep it short and to the point. 0.65. What is the ratio of the Electricity production(% of total) of Chile in 1979 to that in 1980?
Provide a short and direct response. 1. What is the ratio of the Electricity production(% of total) in Guatemala in 1979 to that in 1980?
Give a very brief answer. 1.36. What is the ratio of the Electricity production(% of total) of Malaysia in 1979 to that in 1980?
Offer a terse response. 0.86. What is the ratio of the Electricity production(% of total) of Uruguay in 1979 to that in 1980?
Give a very brief answer. 0.58. What is the ratio of the Electricity production(% of total) of Chile in 1979 to that in 1981?
Ensure brevity in your answer.  0.98. What is the ratio of the Electricity production(% of total) of Guatemala in 1979 to that in 1981?
Your answer should be very brief. 0.97. What is the ratio of the Electricity production(% of total) in Malaysia in 1979 to that in 1981?
Your response must be concise. 0.83. What is the ratio of the Electricity production(% of total) in Uruguay in 1979 to that in 1981?
Make the answer very short. 0.55. What is the ratio of the Electricity production(% of total) of Chile in 1979 to that in 1982?
Give a very brief answer. 0.89. What is the ratio of the Electricity production(% of total) in Guatemala in 1979 to that in 1982?
Make the answer very short. 0.66. What is the ratio of the Electricity production(% of total) of Malaysia in 1979 to that in 1982?
Offer a very short reply. 0.94. What is the ratio of the Electricity production(% of total) in Uruguay in 1979 to that in 1982?
Provide a succinct answer. 0.54. What is the ratio of the Electricity production(% of total) of Chile in 1980 to that in 1981?
Give a very brief answer. 0.98. What is the ratio of the Electricity production(% of total) in Guatemala in 1980 to that in 1981?
Offer a terse response. 0.71. What is the ratio of the Electricity production(% of total) of Malaysia in 1980 to that in 1981?
Provide a short and direct response. 0.97. What is the ratio of the Electricity production(% of total) in Uruguay in 1980 to that in 1981?
Ensure brevity in your answer.  0.96. What is the ratio of the Electricity production(% of total) of Chile in 1980 to that in 1982?
Make the answer very short. 0.89. What is the ratio of the Electricity production(% of total) of Guatemala in 1980 to that in 1982?
Your response must be concise. 0.48. What is the ratio of the Electricity production(% of total) in Malaysia in 1980 to that in 1982?
Offer a terse response. 1.1. What is the ratio of the Electricity production(% of total) in Uruguay in 1980 to that in 1982?
Provide a succinct answer. 0.93. What is the ratio of the Electricity production(% of total) in Chile in 1981 to that in 1982?
Your response must be concise. 0.91. What is the ratio of the Electricity production(% of total) in Guatemala in 1981 to that in 1982?
Offer a very short reply. 0.67. What is the ratio of the Electricity production(% of total) of Malaysia in 1981 to that in 1982?
Offer a very short reply. 1.13. What is the ratio of the Electricity production(% of total) in Uruguay in 1981 to that in 1982?
Make the answer very short. 0.97. What is the difference between the highest and the second highest Electricity production(% of total) in Chile?
Offer a very short reply. 3.8. What is the difference between the highest and the second highest Electricity production(% of total) in Guatemala?
Ensure brevity in your answer.  7.15. What is the difference between the highest and the second highest Electricity production(% of total) of Malaysia?
Provide a succinct answer. 0.44. What is the difference between the highest and the second highest Electricity production(% of total) of Uruguay?
Provide a succinct answer. 2.4. What is the difference between the highest and the lowest Electricity production(% of total) of Chile?
Your response must be concise. 8.2. What is the difference between the highest and the lowest Electricity production(% of total) of Guatemala?
Ensure brevity in your answer.  12.92. What is the difference between the highest and the lowest Electricity production(% of total) in Malaysia?
Your response must be concise. 4.11. What is the difference between the highest and the lowest Electricity production(% of total) in Uruguay?
Ensure brevity in your answer.  37.83. 